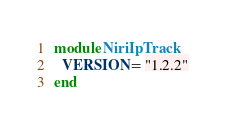Convert code to text. <code><loc_0><loc_0><loc_500><loc_500><_Ruby_>module NiriIpTrack
  VERSION = "1.2.2"
end
</code> 